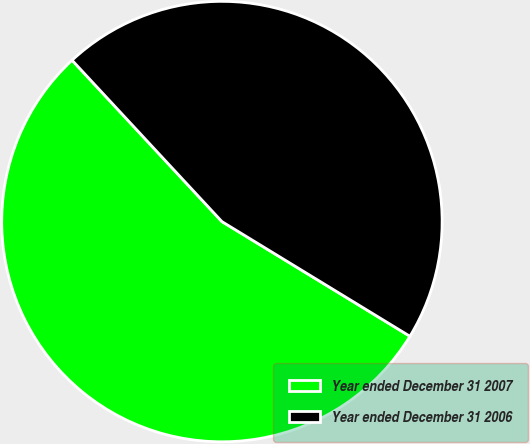<chart> <loc_0><loc_0><loc_500><loc_500><pie_chart><fcel>Year ended December 31 2007<fcel>Year ended December 31 2006<nl><fcel>54.37%<fcel>45.63%<nl></chart> 